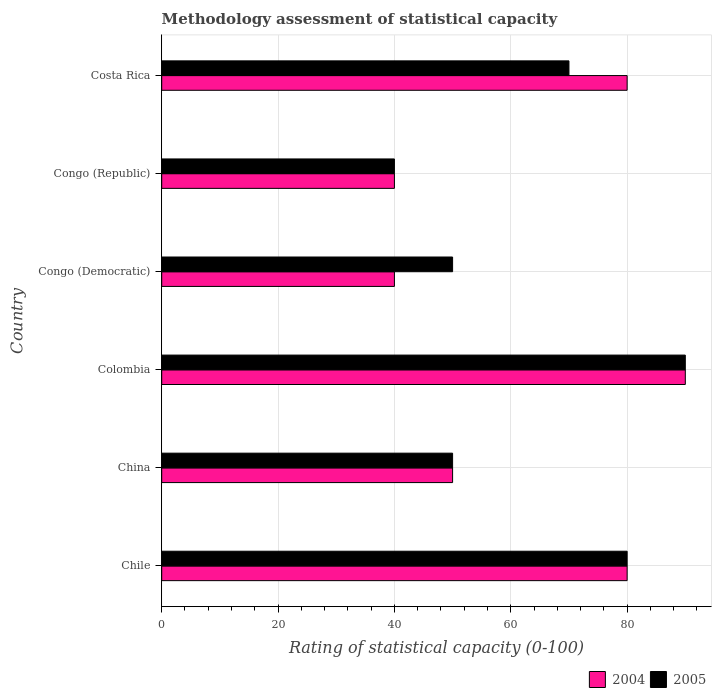How many different coloured bars are there?
Your answer should be very brief. 2. Are the number of bars per tick equal to the number of legend labels?
Offer a terse response. Yes. How many bars are there on the 2nd tick from the bottom?
Give a very brief answer. 2. In how many cases, is the number of bars for a given country not equal to the number of legend labels?
Offer a very short reply. 0. Across all countries, what is the maximum rating of statistical capacity in 2005?
Your answer should be very brief. 90. In which country was the rating of statistical capacity in 2005 maximum?
Make the answer very short. Colombia. In which country was the rating of statistical capacity in 2005 minimum?
Your answer should be very brief. Congo (Republic). What is the total rating of statistical capacity in 2004 in the graph?
Give a very brief answer. 380. What is the average rating of statistical capacity in 2005 per country?
Your response must be concise. 63.33. What is the difference between the rating of statistical capacity in 2004 and rating of statistical capacity in 2005 in Congo (Republic)?
Provide a succinct answer. 0. In how many countries, is the rating of statistical capacity in 2004 greater than 12 ?
Provide a short and direct response. 6. What is the ratio of the rating of statistical capacity in 2004 in Chile to that in Colombia?
Ensure brevity in your answer.  0.89. What is the difference between the highest and the second highest rating of statistical capacity in 2004?
Provide a succinct answer. 10. What is the difference between the highest and the lowest rating of statistical capacity in 2004?
Give a very brief answer. 50. In how many countries, is the rating of statistical capacity in 2005 greater than the average rating of statistical capacity in 2005 taken over all countries?
Your answer should be compact. 3. Is the sum of the rating of statistical capacity in 2005 in China and Congo (Democratic) greater than the maximum rating of statistical capacity in 2004 across all countries?
Provide a short and direct response. Yes. What does the 2nd bar from the top in Chile represents?
Your answer should be compact. 2004. What does the 1st bar from the bottom in Congo (Democratic) represents?
Ensure brevity in your answer.  2004. How many countries are there in the graph?
Provide a succinct answer. 6. What is the difference between two consecutive major ticks on the X-axis?
Provide a succinct answer. 20. Are the values on the major ticks of X-axis written in scientific E-notation?
Ensure brevity in your answer.  No. What is the title of the graph?
Keep it short and to the point. Methodology assessment of statistical capacity. Does "1960" appear as one of the legend labels in the graph?
Your answer should be compact. No. What is the label or title of the X-axis?
Keep it short and to the point. Rating of statistical capacity (0-100). What is the label or title of the Y-axis?
Give a very brief answer. Country. What is the Rating of statistical capacity (0-100) in 2005 in Chile?
Keep it short and to the point. 80. What is the Rating of statistical capacity (0-100) of 2005 in China?
Keep it short and to the point. 50. What is the Rating of statistical capacity (0-100) in 2004 in Colombia?
Your answer should be compact. 90. What is the Rating of statistical capacity (0-100) of 2005 in Congo (Democratic)?
Your answer should be very brief. 50. What is the Rating of statistical capacity (0-100) of 2004 in Congo (Republic)?
Your response must be concise. 40. What is the Rating of statistical capacity (0-100) of 2005 in Congo (Republic)?
Offer a very short reply. 40. What is the Rating of statistical capacity (0-100) of 2004 in Costa Rica?
Make the answer very short. 80. What is the Rating of statistical capacity (0-100) in 2005 in Costa Rica?
Your response must be concise. 70. Across all countries, what is the maximum Rating of statistical capacity (0-100) in 2004?
Your response must be concise. 90. Across all countries, what is the maximum Rating of statistical capacity (0-100) of 2005?
Offer a terse response. 90. What is the total Rating of statistical capacity (0-100) in 2004 in the graph?
Your answer should be very brief. 380. What is the total Rating of statistical capacity (0-100) of 2005 in the graph?
Keep it short and to the point. 380. What is the difference between the Rating of statistical capacity (0-100) in 2005 in Chile and that in China?
Ensure brevity in your answer.  30. What is the difference between the Rating of statistical capacity (0-100) in 2004 in Chile and that in Colombia?
Your answer should be very brief. -10. What is the difference between the Rating of statistical capacity (0-100) of 2005 in Chile and that in Colombia?
Offer a terse response. -10. What is the difference between the Rating of statistical capacity (0-100) in 2004 in Chile and that in Congo (Republic)?
Make the answer very short. 40. What is the difference between the Rating of statistical capacity (0-100) in 2005 in Chile and that in Congo (Republic)?
Offer a terse response. 40. What is the difference between the Rating of statistical capacity (0-100) in 2004 in Chile and that in Costa Rica?
Provide a short and direct response. 0. What is the difference between the Rating of statistical capacity (0-100) of 2005 in Chile and that in Costa Rica?
Your answer should be very brief. 10. What is the difference between the Rating of statistical capacity (0-100) of 2004 in China and that in Colombia?
Offer a very short reply. -40. What is the difference between the Rating of statistical capacity (0-100) in 2005 in China and that in Colombia?
Offer a very short reply. -40. What is the difference between the Rating of statistical capacity (0-100) in 2005 in China and that in Congo (Democratic)?
Offer a terse response. 0. What is the difference between the Rating of statistical capacity (0-100) of 2004 in China and that in Congo (Republic)?
Keep it short and to the point. 10. What is the difference between the Rating of statistical capacity (0-100) of 2005 in China and that in Congo (Republic)?
Give a very brief answer. 10. What is the difference between the Rating of statistical capacity (0-100) of 2005 in China and that in Costa Rica?
Ensure brevity in your answer.  -20. What is the difference between the Rating of statistical capacity (0-100) of 2004 in Colombia and that in Congo (Republic)?
Your answer should be very brief. 50. What is the difference between the Rating of statistical capacity (0-100) of 2005 in Colombia and that in Congo (Republic)?
Offer a terse response. 50. What is the difference between the Rating of statistical capacity (0-100) in 2005 in Congo (Democratic) and that in Congo (Republic)?
Make the answer very short. 10. What is the difference between the Rating of statistical capacity (0-100) of 2004 in Congo (Democratic) and that in Costa Rica?
Your answer should be compact. -40. What is the difference between the Rating of statistical capacity (0-100) of 2005 in Congo (Democratic) and that in Costa Rica?
Give a very brief answer. -20. What is the difference between the Rating of statistical capacity (0-100) in 2004 in Chile and the Rating of statistical capacity (0-100) in 2005 in China?
Provide a succinct answer. 30. What is the difference between the Rating of statistical capacity (0-100) of 2004 in Chile and the Rating of statistical capacity (0-100) of 2005 in Congo (Democratic)?
Provide a succinct answer. 30. What is the difference between the Rating of statistical capacity (0-100) of 2004 in Chile and the Rating of statistical capacity (0-100) of 2005 in Congo (Republic)?
Keep it short and to the point. 40. What is the difference between the Rating of statistical capacity (0-100) of 2004 in Chile and the Rating of statistical capacity (0-100) of 2005 in Costa Rica?
Make the answer very short. 10. What is the difference between the Rating of statistical capacity (0-100) in 2004 in China and the Rating of statistical capacity (0-100) in 2005 in Colombia?
Your response must be concise. -40. What is the difference between the Rating of statistical capacity (0-100) of 2004 in Colombia and the Rating of statistical capacity (0-100) of 2005 in Congo (Democratic)?
Keep it short and to the point. 40. What is the difference between the Rating of statistical capacity (0-100) in 2004 in Congo (Democratic) and the Rating of statistical capacity (0-100) in 2005 in Congo (Republic)?
Provide a short and direct response. 0. What is the difference between the Rating of statistical capacity (0-100) in 2004 in Congo (Democratic) and the Rating of statistical capacity (0-100) in 2005 in Costa Rica?
Keep it short and to the point. -30. What is the difference between the Rating of statistical capacity (0-100) of 2004 in Congo (Republic) and the Rating of statistical capacity (0-100) of 2005 in Costa Rica?
Your answer should be compact. -30. What is the average Rating of statistical capacity (0-100) of 2004 per country?
Your answer should be compact. 63.33. What is the average Rating of statistical capacity (0-100) of 2005 per country?
Your answer should be very brief. 63.33. What is the difference between the Rating of statistical capacity (0-100) of 2004 and Rating of statistical capacity (0-100) of 2005 in Colombia?
Your answer should be compact. 0. What is the difference between the Rating of statistical capacity (0-100) of 2004 and Rating of statistical capacity (0-100) of 2005 in Congo (Democratic)?
Provide a short and direct response. -10. What is the difference between the Rating of statistical capacity (0-100) in 2004 and Rating of statistical capacity (0-100) in 2005 in Costa Rica?
Make the answer very short. 10. What is the ratio of the Rating of statistical capacity (0-100) of 2004 in Chile to that in China?
Offer a terse response. 1.6. What is the ratio of the Rating of statistical capacity (0-100) in 2004 in Chile to that in Colombia?
Offer a very short reply. 0.89. What is the ratio of the Rating of statistical capacity (0-100) in 2005 in Chile to that in Colombia?
Provide a short and direct response. 0.89. What is the ratio of the Rating of statistical capacity (0-100) of 2004 in Chile to that in Congo (Democratic)?
Offer a terse response. 2. What is the ratio of the Rating of statistical capacity (0-100) of 2005 in Chile to that in Congo (Democratic)?
Your answer should be compact. 1.6. What is the ratio of the Rating of statistical capacity (0-100) of 2004 in Chile to that in Congo (Republic)?
Ensure brevity in your answer.  2. What is the ratio of the Rating of statistical capacity (0-100) of 2005 in Chile to that in Congo (Republic)?
Your answer should be very brief. 2. What is the ratio of the Rating of statistical capacity (0-100) of 2004 in Chile to that in Costa Rica?
Give a very brief answer. 1. What is the ratio of the Rating of statistical capacity (0-100) of 2004 in China to that in Colombia?
Offer a terse response. 0.56. What is the ratio of the Rating of statistical capacity (0-100) in 2005 in China to that in Colombia?
Give a very brief answer. 0.56. What is the ratio of the Rating of statistical capacity (0-100) in 2004 in China to that in Congo (Democratic)?
Your response must be concise. 1.25. What is the ratio of the Rating of statistical capacity (0-100) of 2004 in China to that in Congo (Republic)?
Your answer should be compact. 1.25. What is the ratio of the Rating of statistical capacity (0-100) in 2005 in China to that in Congo (Republic)?
Provide a succinct answer. 1.25. What is the ratio of the Rating of statistical capacity (0-100) of 2004 in Colombia to that in Congo (Democratic)?
Provide a short and direct response. 2.25. What is the ratio of the Rating of statistical capacity (0-100) in 2004 in Colombia to that in Congo (Republic)?
Your answer should be compact. 2.25. What is the ratio of the Rating of statistical capacity (0-100) in 2005 in Colombia to that in Congo (Republic)?
Keep it short and to the point. 2.25. What is the difference between the highest and the second highest Rating of statistical capacity (0-100) of 2004?
Offer a terse response. 10. What is the difference between the highest and the second highest Rating of statistical capacity (0-100) of 2005?
Ensure brevity in your answer.  10. 